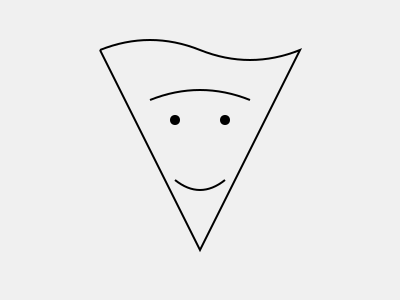As an author of historical fiction, you often research iconic figures from the past. Identify the famous historical figure depicted in this stylized portrait outline, known for leading a nonviolent independence movement in the 20th century. 1. Examine the overall shape of the portrait outline:
   - The figure has a distinctive round head shape.
   - There's a noticeable lack of hair, indicating baldness.

2. Look at the facial features:
   - The eyes are represented by small circles, giving a wise and kind appearance.
   - The nose is not prominently featured.
   - There's a curved line representing a smile or mustache.

3. Consider the historical context provided:
   - The question mentions a leader of a nonviolent independence movement in the 20th century.

4. Compare these characteristics to well-known historical figures:
   - The round head, baldness, and kind expression are iconic features of Mahatma Gandhi.
   - Gandhi led India's nonviolent independence movement against British rule in the 20th century.

5. Confirm the match:
   - The stylized portrait aligns with common depictions of Gandhi in art and media.
   - Gandhi's philosophy of nonviolence and his role in India's independence make him a significant figure in 20th-century history.

Given these factors, the historical figure depicted in this stylized portrait outline is Mahatma Gandhi.
Answer: Mahatma Gandhi 